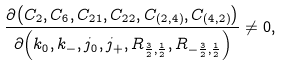Convert formula to latex. <formula><loc_0><loc_0><loc_500><loc_500>\frac { \partial { \left ( C _ { 2 } , C _ { 6 } , C _ { 2 1 } , C _ { 2 2 } , C _ { ( 2 , 4 ) } , C _ { ( 4 , 2 ) } \right ) } } { \partial { \left ( k _ { 0 } , k _ { - } , j _ { 0 } , j _ { + } , R _ { \frac { 3 } { 2 } , \frac { 1 } { 2 } } , R _ { - \frac { 3 } { 2 } , \frac { 1 } { 2 } } \right ) } } \neq 0 ,</formula> 